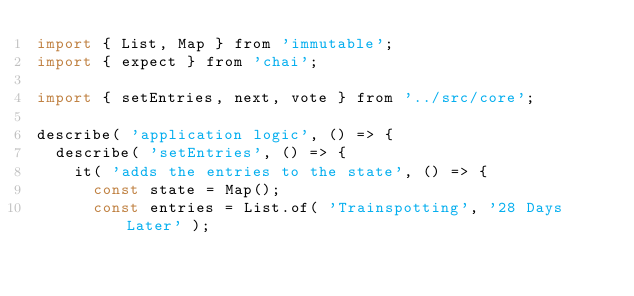Convert code to text. <code><loc_0><loc_0><loc_500><loc_500><_JavaScript_>import { List, Map } from 'immutable';
import { expect } from 'chai';

import { setEntries, next, vote } from '../src/core';

describe( 'application logic', () => {
  describe( 'setEntries', () => {
    it( 'adds the entries to the state', () => {
      const state = Map();
      const entries = List.of( 'Trainspotting', '28 Days Later' );</code> 